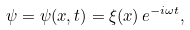Convert formula to latex. <formula><loc_0><loc_0><loc_500><loc_500>\psi = \psi ( x , t ) = \xi ( x ) \, e ^ { - i \omega t } ,</formula> 